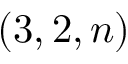Convert formula to latex. <formula><loc_0><loc_0><loc_500><loc_500>( 3 , 2 , n )</formula> 